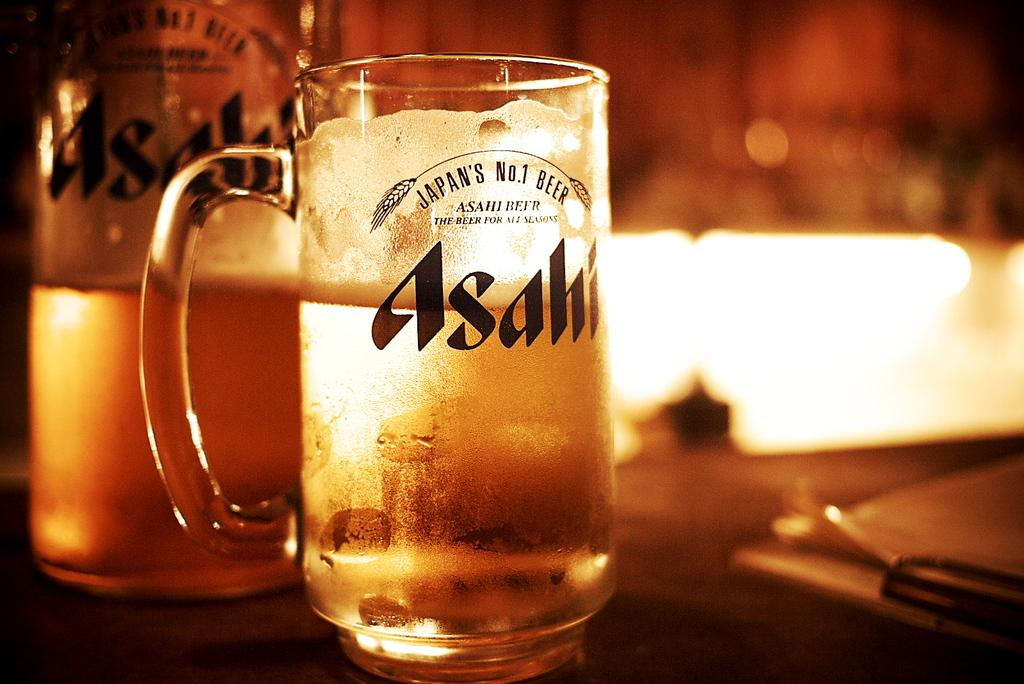<image>
Give a short and clear explanation of the subsequent image. A clear glass of Japan's No.1 Beer called Asahi is almost full. 